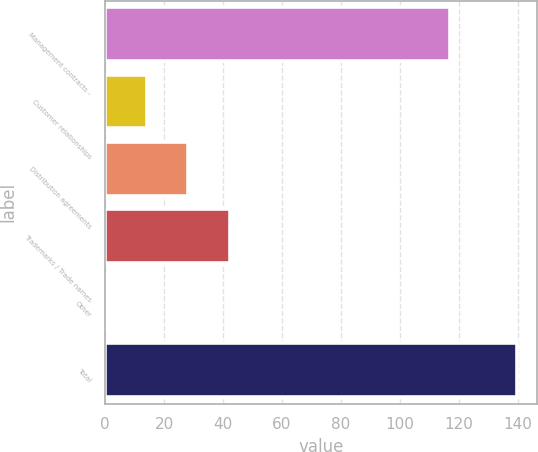<chart> <loc_0><loc_0><loc_500><loc_500><bar_chart><fcel>Management contracts -<fcel>Customer relationships<fcel>Distribution agreements<fcel>Trademarks / Trade names<fcel>Other<fcel>Total<nl><fcel>117<fcel>14.33<fcel>28.26<fcel>42.19<fcel>0.4<fcel>139.7<nl></chart> 